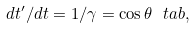<formula> <loc_0><loc_0><loc_500><loc_500>d t ^ { \prime } / d t = 1 / \gamma = \cos \theta \ t a b ,</formula> 